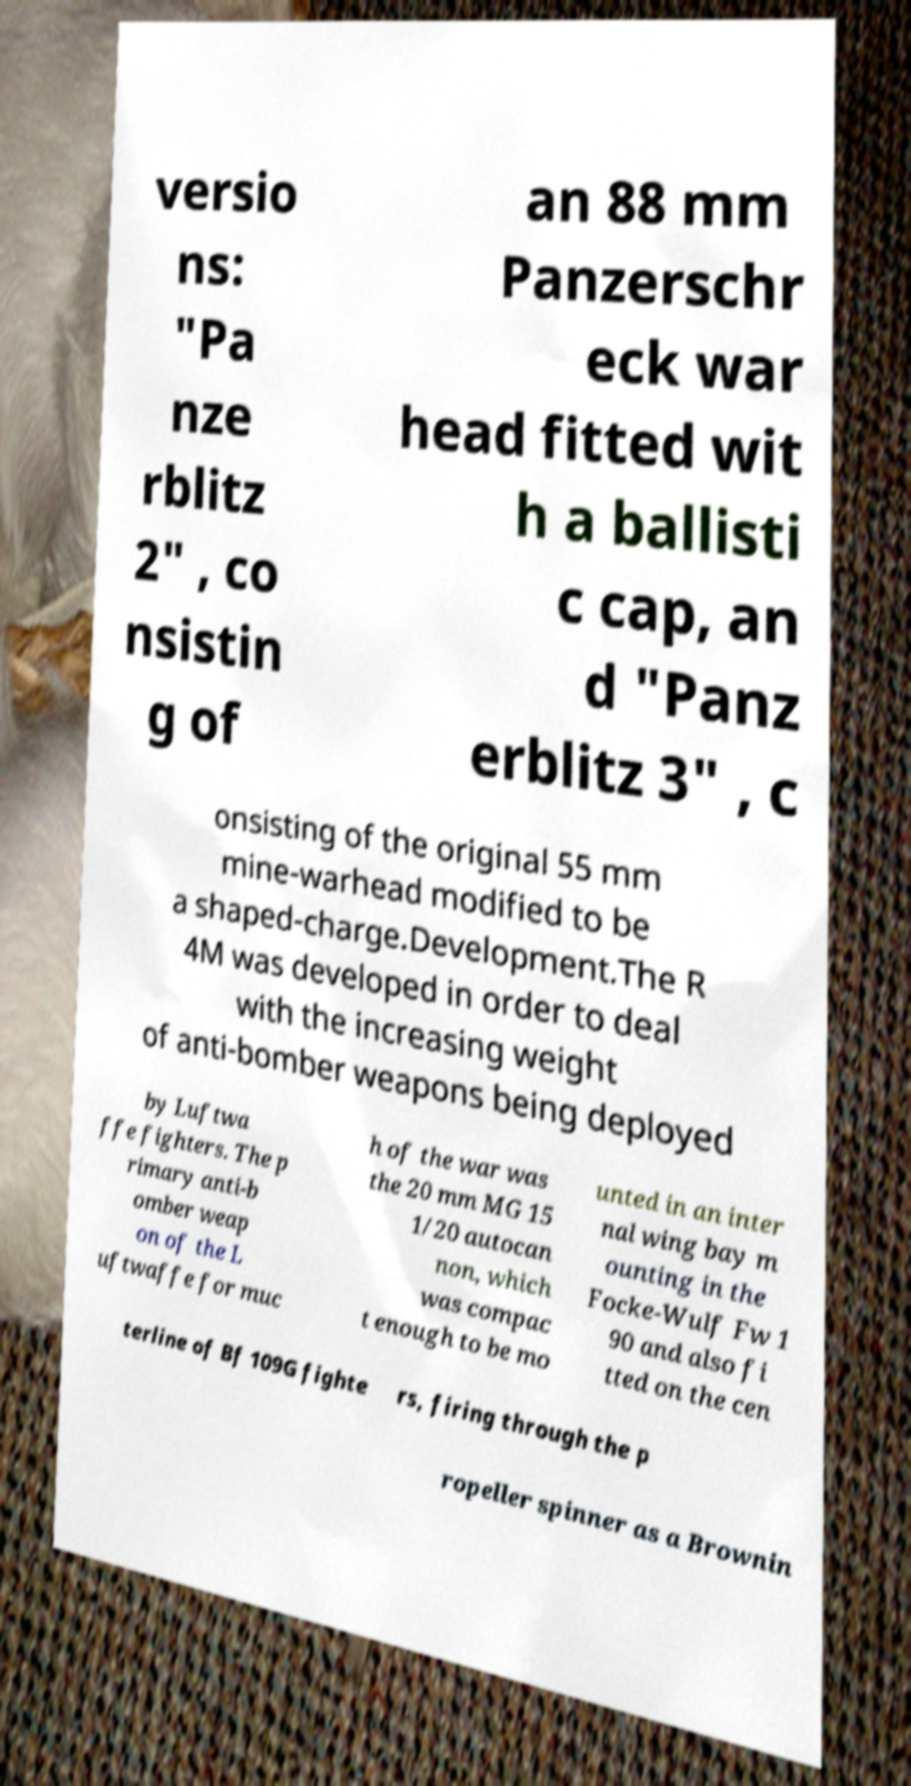Please read and relay the text visible in this image. What does it say? versio ns: "Pa nze rblitz 2" , co nsistin g of an 88 mm Panzerschr eck war head fitted wit h a ballisti c cap, an d "Panz erblitz 3" , c onsisting of the original 55 mm mine-warhead modified to be a shaped-charge.Development.The R 4M was developed in order to deal with the increasing weight of anti-bomber weapons being deployed by Luftwa ffe fighters. The p rimary anti-b omber weap on of the L uftwaffe for muc h of the war was the 20 mm MG 15 1/20 autocan non, which was compac t enough to be mo unted in an inter nal wing bay m ounting in the Focke-Wulf Fw 1 90 and also fi tted on the cen terline of Bf 109G fighte rs, firing through the p ropeller spinner as a Brownin 